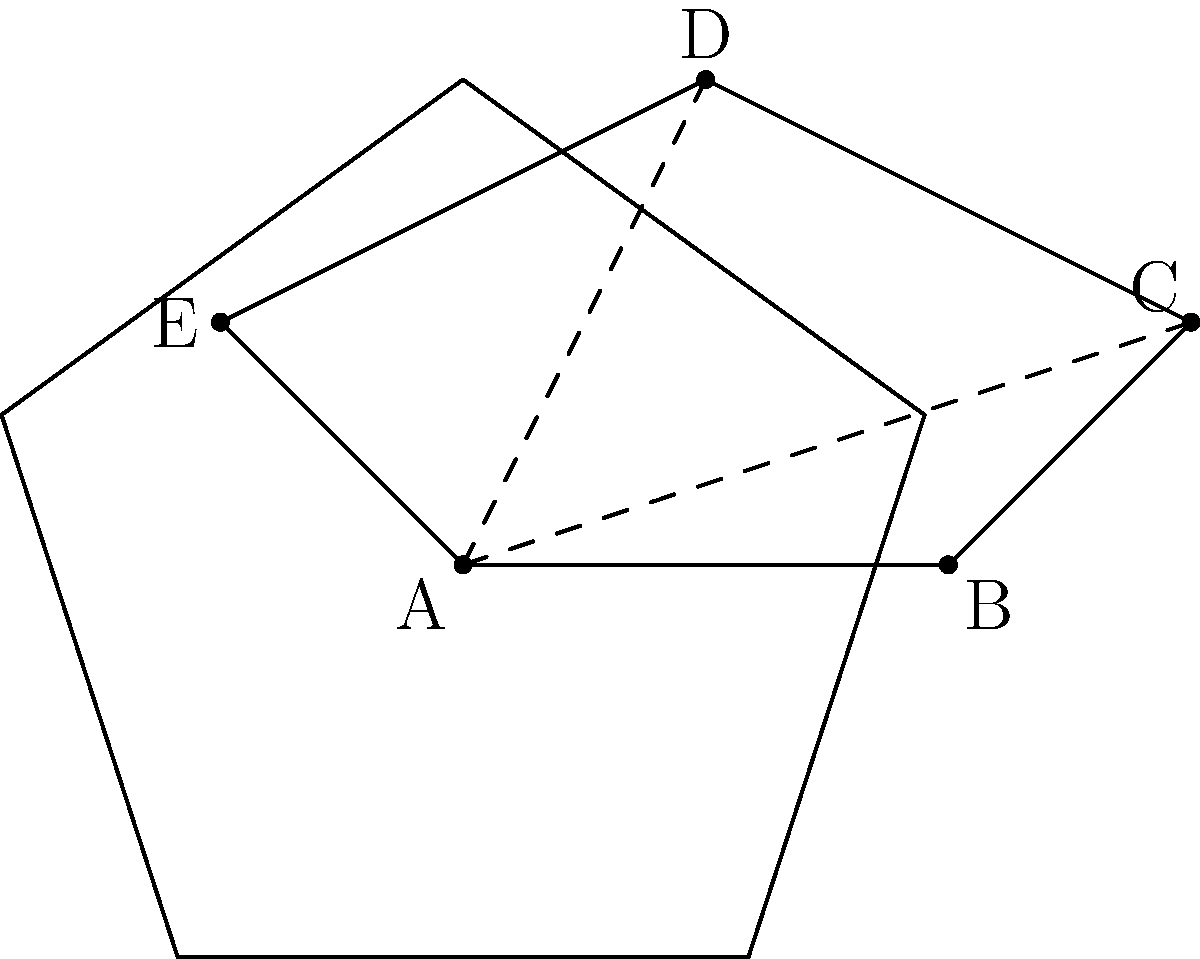In the diagram representing a ship's internal layout, security personnel need to find the shortest path from point A to point D. Which of the following routes provides the shortest distance: A-B-C-D, A-E-D, or A-D directly? Calculate the length of the shortest path. To find the shortest path, we need to calculate and compare the lengths of the given routes:

1. Route A-B-C-D:
   Length = AB + BC + CD
   AB = 1, BC = $\sqrt{0.5^2 + 0.5^2} = \frac{\sqrt{2}}{2}$, CD = $\sqrt{1^2 + 0.5^2} = \frac{\sqrt{5}}{2}$
   Total = $1 + \frac{\sqrt{2}}{2} + \frac{\sqrt{5}}{2}$

2. Route A-E-D:
   Length = AE + ED
   AE = $\sqrt{0.5^2 + 0.5^2} = \frac{\sqrt{2}}{2}$, ED = 1
   Total = $\frac{\sqrt{2}}{2} + 1$

3. Route A-D directly:
   Length = AD = $\sqrt{0.5^2 + 1^2} = \frac{\sqrt{5}}{2}$

Comparing the results:
- A-B-C-D: $1 + \frac{\sqrt{2}}{2} + \frac{\sqrt{5}}{2} \approx 2.62$
- A-E-D: $\frac{\sqrt{2}}{2} + 1 \approx 1.71$
- A-D: $\frac{\sqrt{5}}{2} \approx 1.12$

The shortest path is the direct route A-D with a length of $\frac{\sqrt{5}}{2}$.
Answer: $\frac{\sqrt{5}}{2}$ 